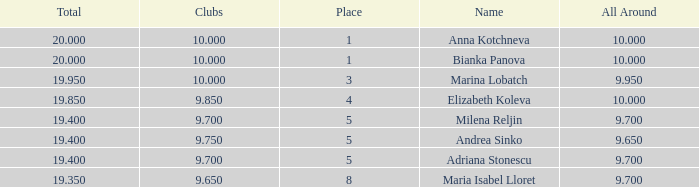What total has 10 as the clubs, with a place greater than 1? 19.95. 